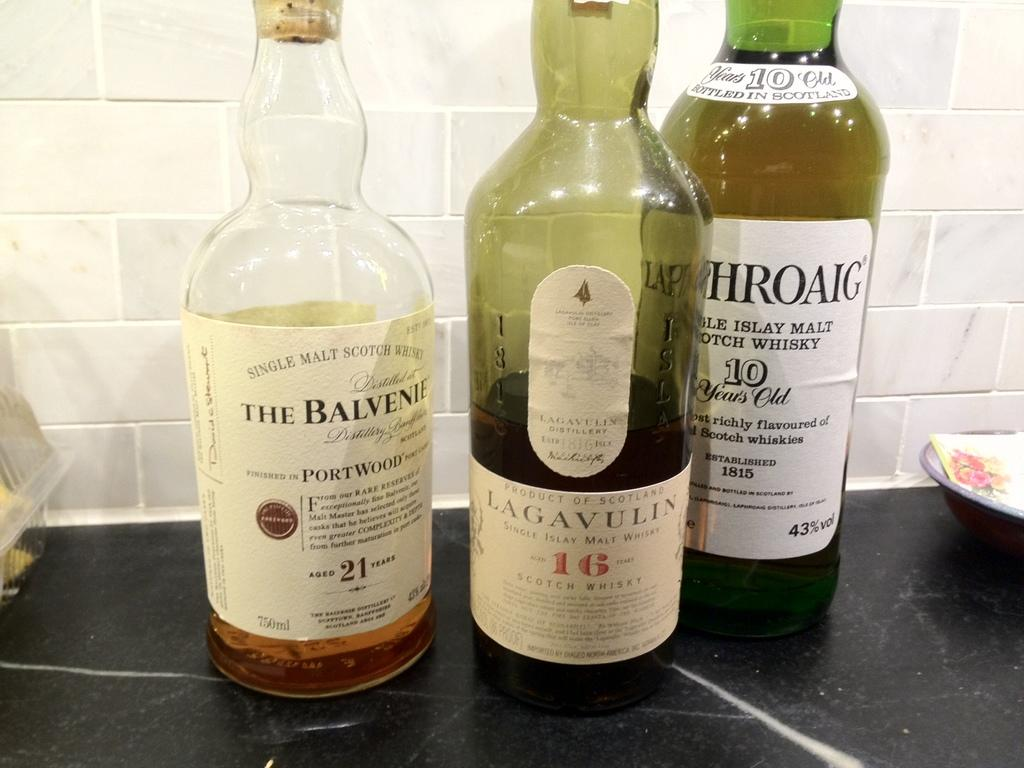<image>
Summarize the visual content of the image. A bottle of Lagavulin Scotch Whisky is in between two other alcohol bottles on a counter. 